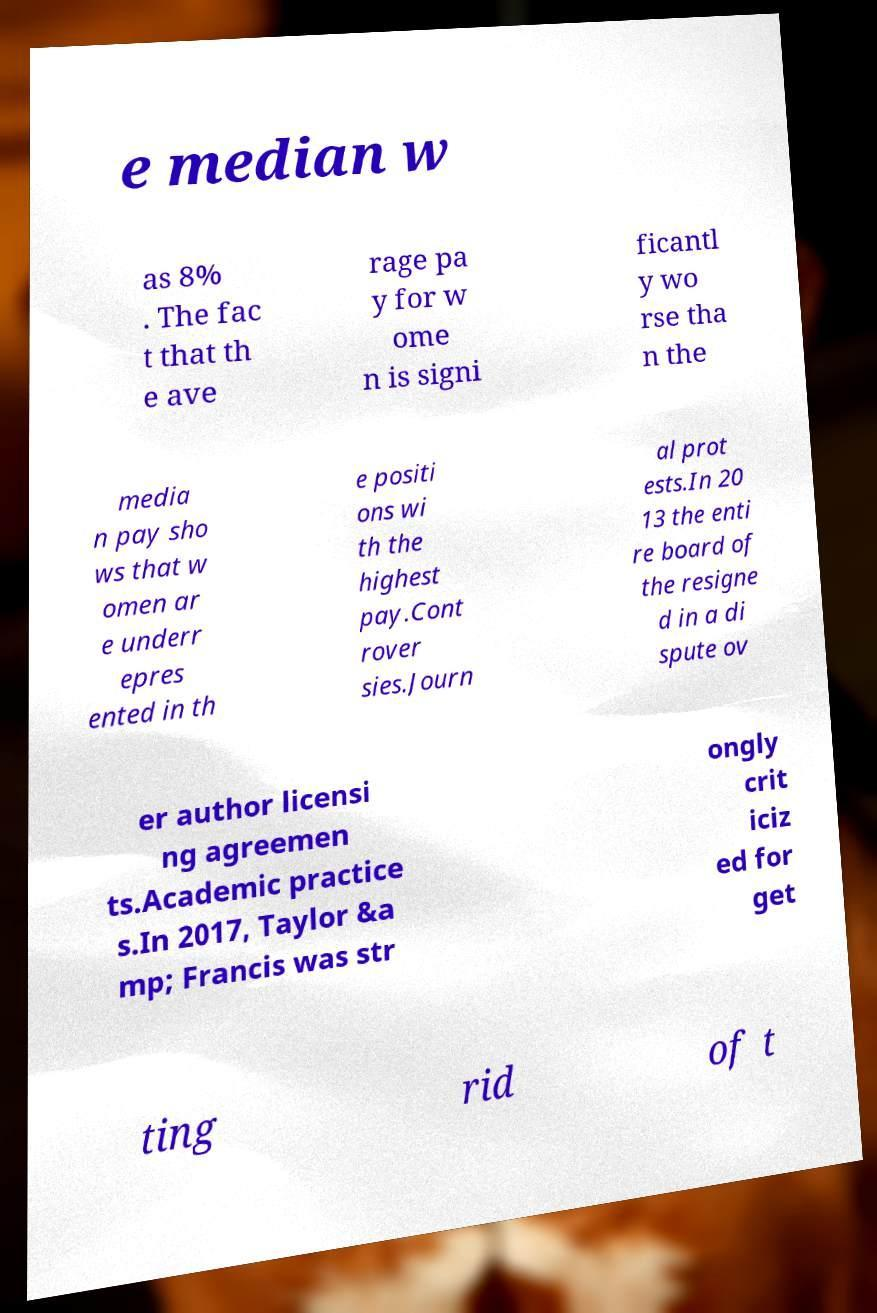Could you extract and type out the text from this image? e median w as 8% . The fac t that th e ave rage pa y for w ome n is signi ficantl y wo rse tha n the media n pay sho ws that w omen ar e underr epres ented in th e positi ons wi th the highest pay.Cont rover sies.Journ al prot ests.In 20 13 the enti re board of the resigne d in a di spute ov er author licensi ng agreemen ts.Academic practice s.In 2017, Taylor &a mp; Francis was str ongly crit iciz ed for get ting rid of t 